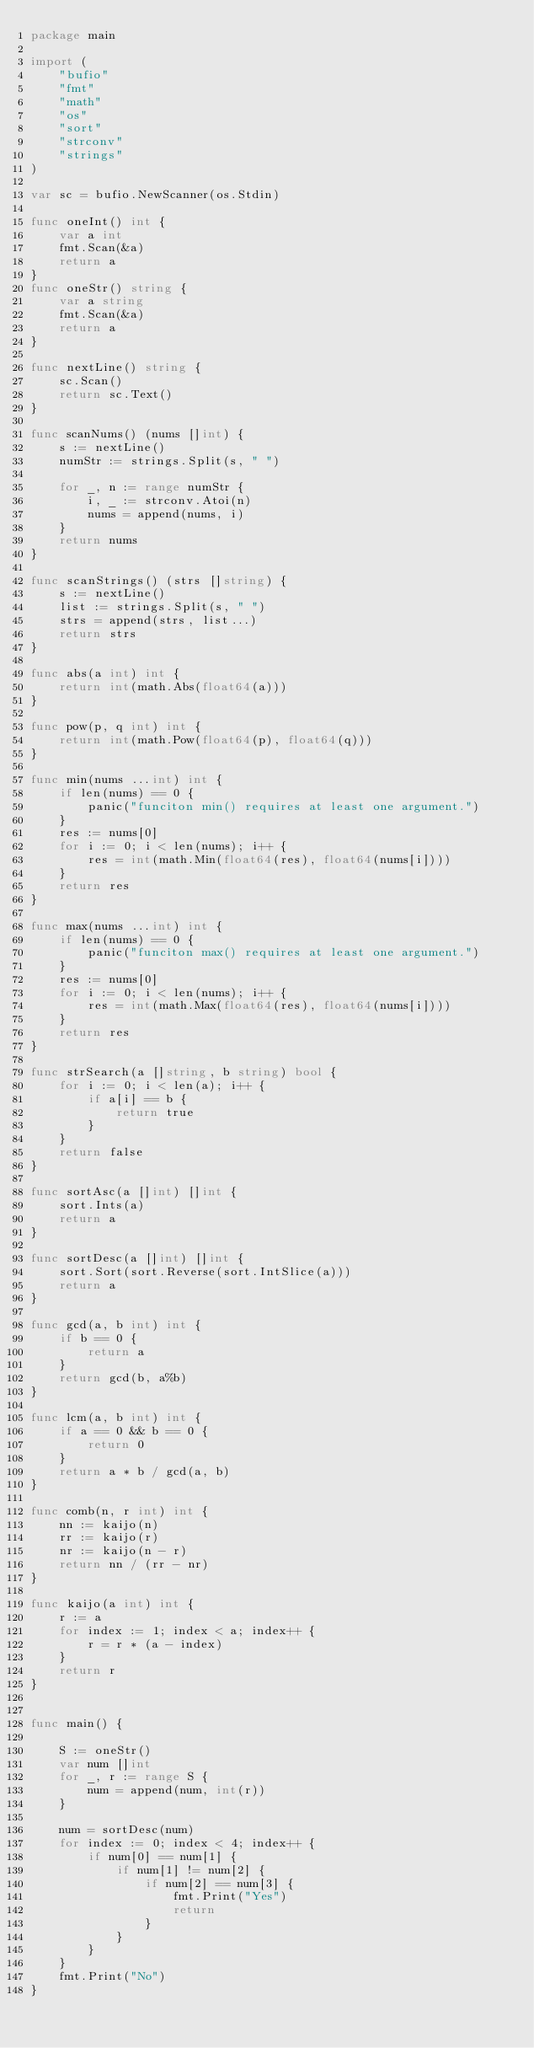Convert code to text. <code><loc_0><loc_0><loc_500><loc_500><_Go_>package main

import (
	"bufio"
	"fmt"
	"math"
	"os"
	"sort"
	"strconv"
	"strings"
)

var sc = bufio.NewScanner(os.Stdin)

func oneInt() int {
	var a int
	fmt.Scan(&a)
	return a
}
func oneStr() string {
	var a string
	fmt.Scan(&a)
	return a
}

func nextLine() string {
	sc.Scan()
	return sc.Text()
}

func scanNums() (nums []int) {
	s := nextLine()
	numStr := strings.Split(s, " ")

	for _, n := range numStr {
		i, _ := strconv.Atoi(n)
		nums = append(nums, i)
	}
	return nums
}

func scanStrings() (strs []string) {
	s := nextLine()
	list := strings.Split(s, " ")
	strs = append(strs, list...)
	return strs
}

func abs(a int) int {
	return int(math.Abs(float64(a)))
}

func pow(p, q int) int {
	return int(math.Pow(float64(p), float64(q)))
}

func min(nums ...int) int {
	if len(nums) == 0 {
		panic("funciton min() requires at least one argument.")
	}
	res := nums[0]
	for i := 0; i < len(nums); i++ {
		res = int(math.Min(float64(res), float64(nums[i])))
	}
	return res
}

func max(nums ...int) int {
	if len(nums) == 0 {
		panic("funciton max() requires at least one argument.")
	}
	res := nums[0]
	for i := 0; i < len(nums); i++ {
		res = int(math.Max(float64(res), float64(nums[i])))
	}
	return res
}

func strSearch(a []string, b string) bool {
	for i := 0; i < len(a); i++ {
		if a[i] == b {
			return true
		}
	}
	return false
}

func sortAsc(a []int) []int {
	sort.Ints(a)
	return a
}

func sortDesc(a []int) []int {
	sort.Sort(sort.Reverse(sort.IntSlice(a)))
	return a
}

func gcd(a, b int) int {
	if b == 0 {
		return a
	}
	return gcd(b, a%b)
}

func lcm(a, b int) int {
	if a == 0 && b == 0 {
		return 0
	}
	return a * b / gcd(a, b)
}

func comb(n, r int) int {
	nn := kaijo(n)
	rr := kaijo(r)
	nr := kaijo(n - r)
	return nn / (rr - nr)
}

func kaijo(a int) int {
	r := a
	for index := 1; index < a; index++ {
		r = r * (a - index)
	}
	return r
}


func main() {

	S := oneStr()
	var num []int
	for _, r := range S {
		num = append(num, int(r))
	}

	num = sortDesc(num)
	for index := 0; index < 4; index++ {
		if num[0] == num[1] {
			if num[1] != num[2] {
				if num[2] == num[3] {
					fmt.Print("Yes")
					return
				}
			}
		}
	}
	fmt.Print("No")
}
</code> 